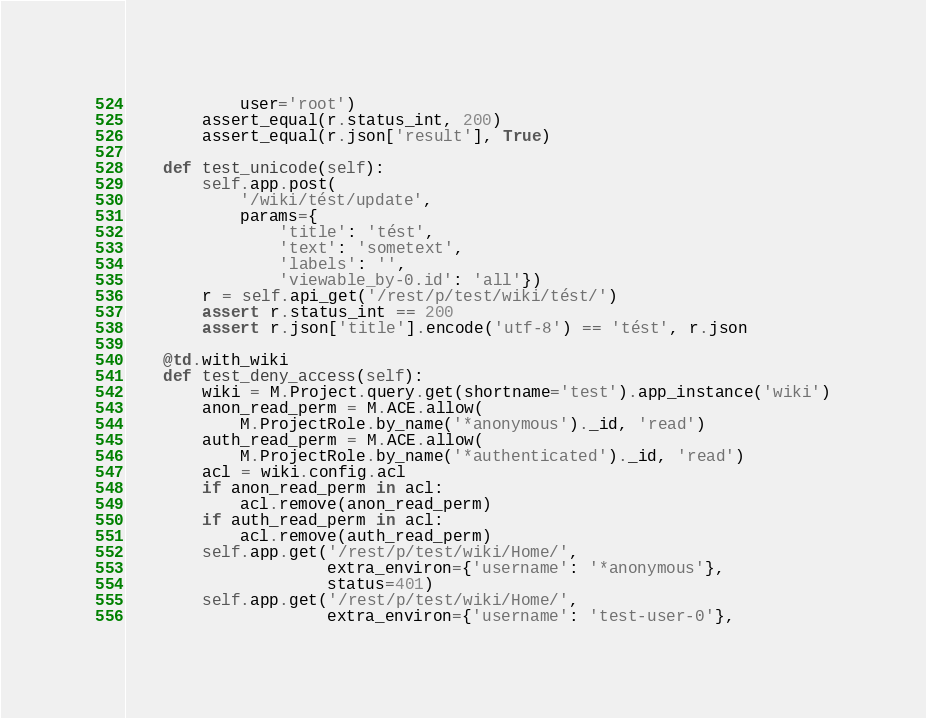Convert code to text. <code><loc_0><loc_0><loc_500><loc_500><_Python_>            user='root')
        assert_equal(r.status_int, 200)
        assert_equal(r.json['result'], True)

    def test_unicode(self):
        self.app.post(
            '/wiki/tést/update',
            params={
                'title': 'tést',
                'text': 'sometext',
                'labels': '',
                'viewable_by-0.id': 'all'})
        r = self.api_get('/rest/p/test/wiki/tést/')
        assert r.status_int == 200
        assert r.json['title'].encode('utf-8') == 'tést', r.json

    @td.with_wiki
    def test_deny_access(self):
        wiki = M.Project.query.get(shortname='test').app_instance('wiki')
        anon_read_perm = M.ACE.allow(
            M.ProjectRole.by_name('*anonymous')._id, 'read')
        auth_read_perm = M.ACE.allow(
            M.ProjectRole.by_name('*authenticated')._id, 'read')
        acl = wiki.config.acl
        if anon_read_perm in acl:
            acl.remove(anon_read_perm)
        if auth_read_perm in acl:
            acl.remove(auth_read_perm)
        self.app.get('/rest/p/test/wiki/Home/',
                     extra_environ={'username': '*anonymous'},
                     status=401)
        self.app.get('/rest/p/test/wiki/Home/',
                     extra_environ={'username': 'test-user-0'},</code> 